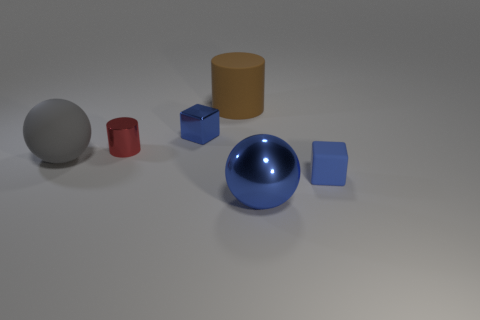Subtract all gray balls. How many balls are left? 1 Add 2 blue metal cubes. How many objects exist? 8 Subtract all blocks. How many objects are left? 4 Subtract 2 balls. How many balls are left? 0 Add 1 large matte things. How many large matte things exist? 3 Subtract 0 cyan cylinders. How many objects are left? 6 Subtract all brown cylinders. Subtract all gray spheres. How many cylinders are left? 1 Subtract all small things. Subtract all large cyan metal objects. How many objects are left? 3 Add 3 red metal cylinders. How many red metal cylinders are left? 4 